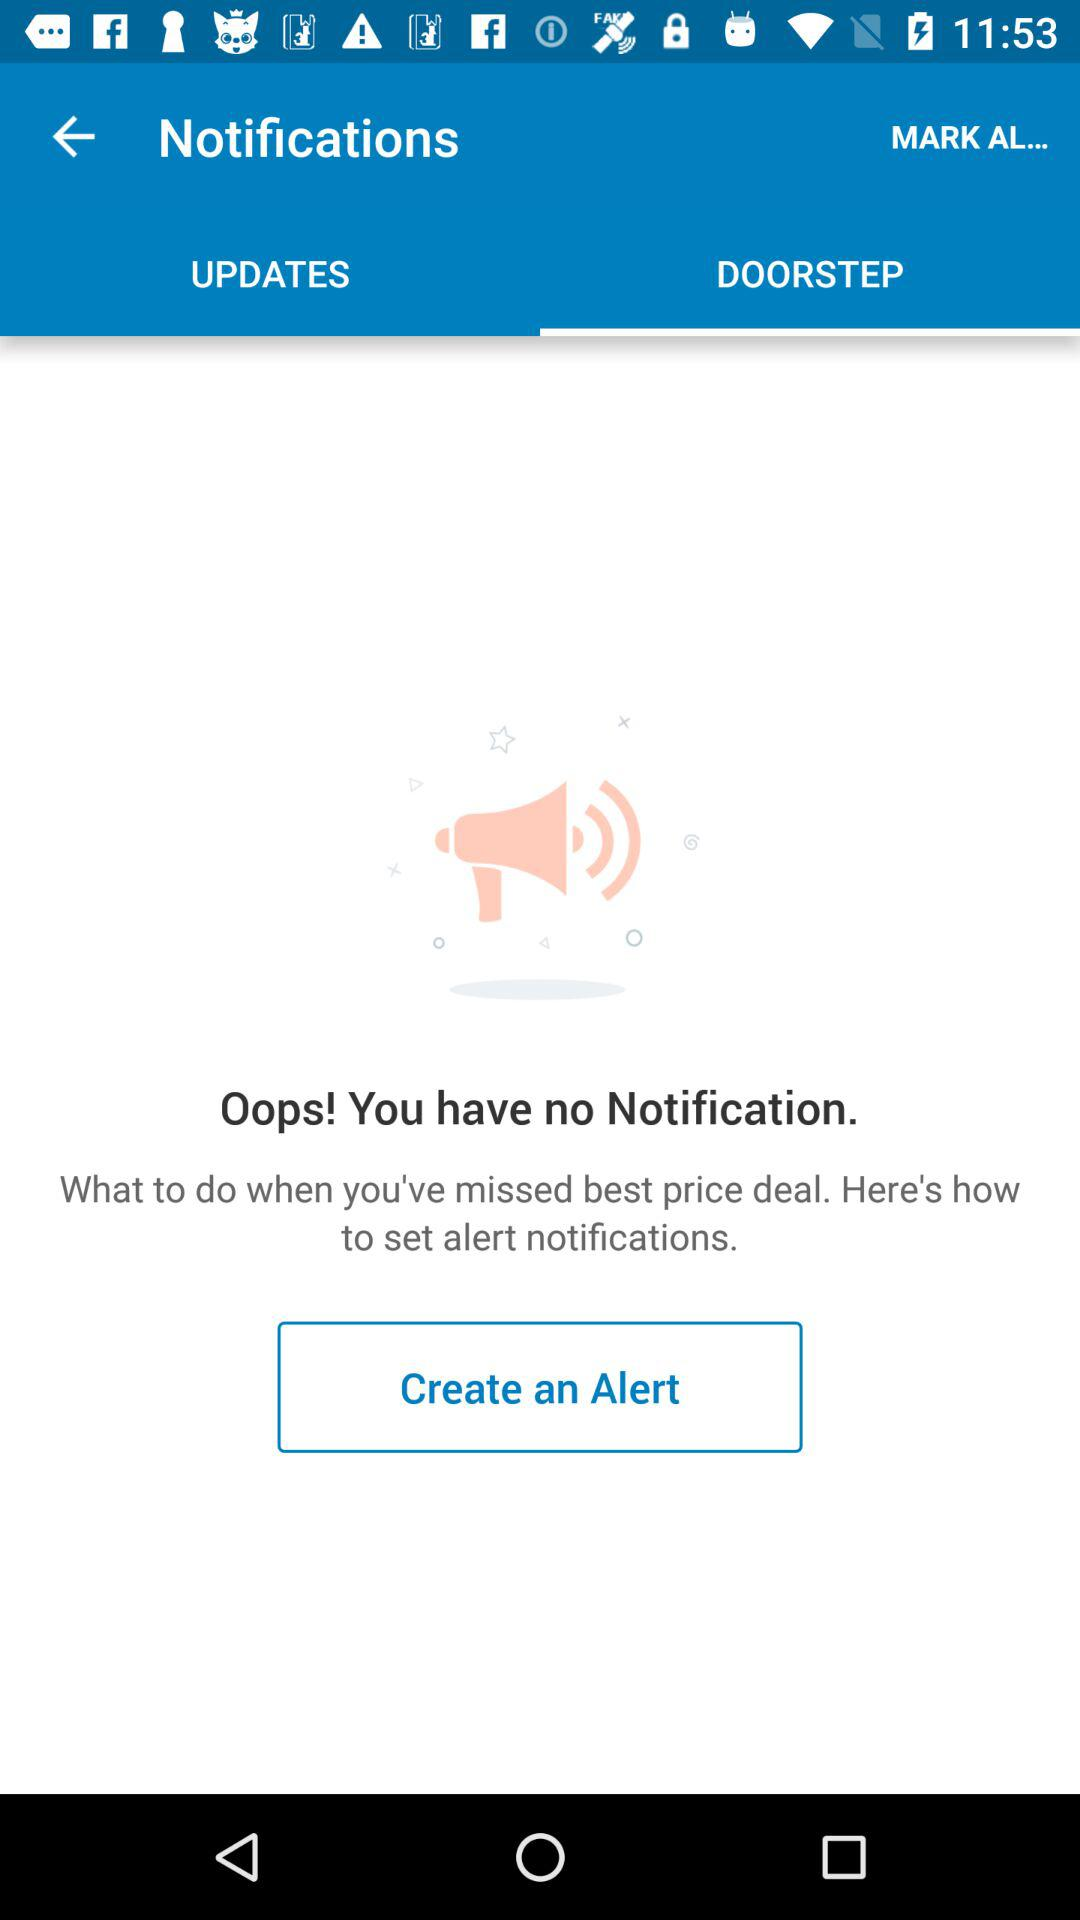Is there any notification? There is no notification. 